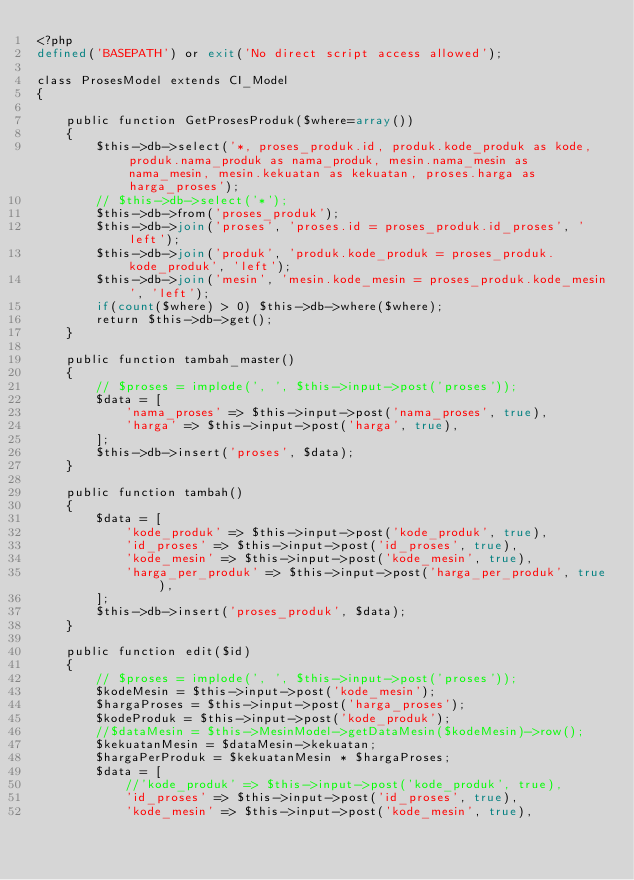Convert code to text. <code><loc_0><loc_0><loc_500><loc_500><_PHP_><?php
defined('BASEPATH') or exit('No direct script access allowed');

class ProsesModel extends CI_Model
{

	public function GetProsesProduk($where=array())
	{
		$this->db->select('*, proses_produk.id, produk.kode_produk as kode, produk.nama_produk as nama_produk, mesin.nama_mesin as nama_mesin, mesin.kekuatan as kekuatan, proses.harga as harga_proses');
		// $this->db->select('*');
		$this->db->from('proses_produk');
		$this->db->join('proses', 'proses.id = proses_produk.id_proses', 'left');
		$this->db->join('produk', 'produk.kode_produk = proses_produk.kode_produk', 'left');
		$this->db->join('mesin', 'mesin.kode_mesin = proses_produk.kode_mesin', 'left');
		if(count($where) > 0) $this->db->where($where);
		return $this->db->get();
	}

	public function tambah_master()
	{
		// $proses = implode(', ', $this->input->post('proses'));
		$data = [
			'nama_proses' => $this->input->post('nama_proses', true),
			'harga' => $this->input->post('harga', true),
		];
		$this->db->insert('proses', $data);
	}

	public function tambah()
	{
		$data = [
			'kode_produk' => $this->input->post('kode_produk', true),
			'id_proses' => $this->input->post('id_proses', true),
			'kode_mesin' => $this->input->post('kode_mesin', true),
			'harga_per_produk' => $this->input->post('harga_per_produk', true),
		];
		$this->db->insert('proses_produk', $data);
	}

	public function edit($id)
	{
		// $proses = implode(', ', $this->input->post('proses'));
		$kodeMesin = $this->input->post('kode_mesin');
		$hargaProses = $this->input->post('harga_proses');
		$kodeProduk = $this->input->post('kode_produk');
		//$dataMesin = $this->MesinModel->getDataMesin($kodeMesin)->row();
		$kekuatanMesin = $dataMesin->kekuatan;
		$hargaPerProduk = $kekuatanMesin * $hargaProses;
		$data = [
			//'kode_produk' => $this->input->post('kode_produk', true),
			'id_proses' => $this->input->post('id_proses', true),
			'kode_mesin' => $this->input->post('kode_mesin', true),</code> 